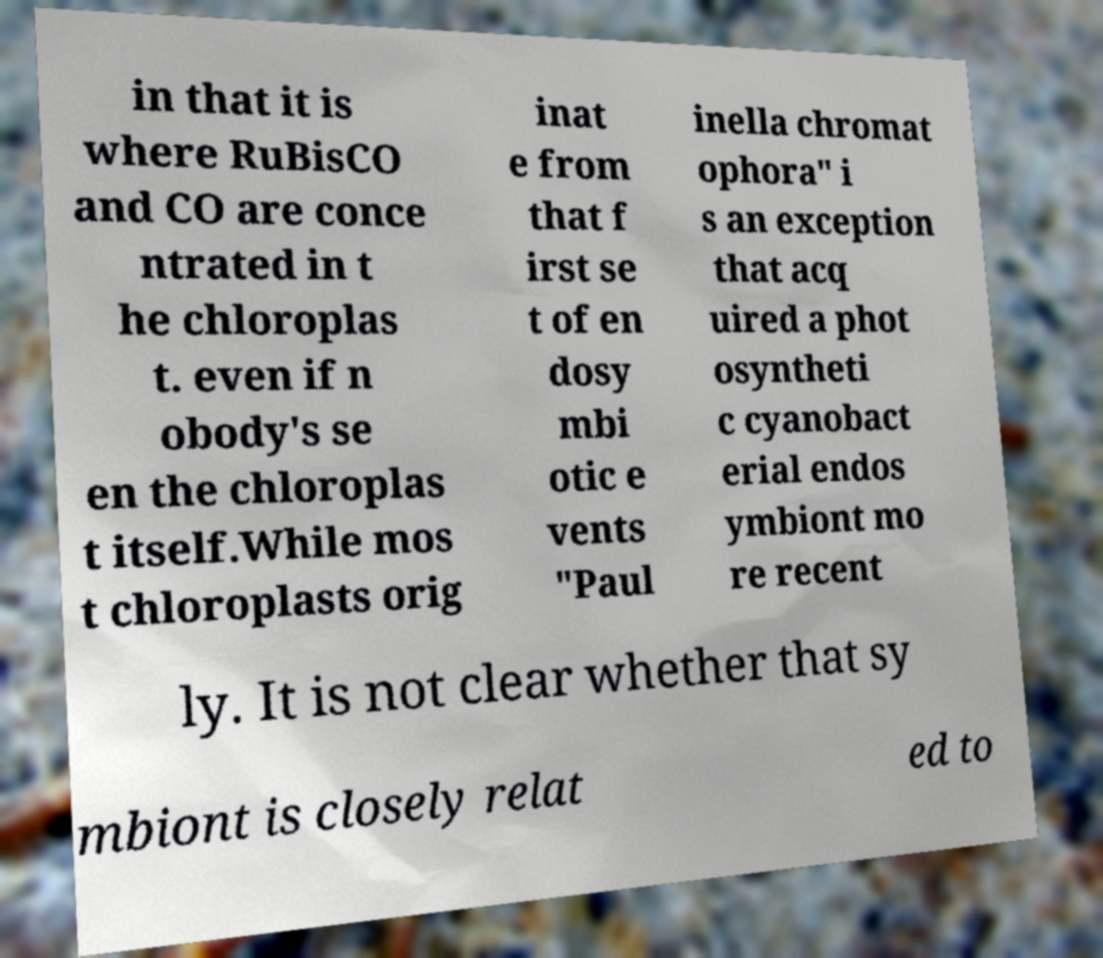Can you accurately transcribe the text from the provided image for me? in that it is where RuBisCO and CO are conce ntrated in t he chloroplas t. even if n obody's se en the chloroplas t itself.While mos t chloroplasts orig inat e from that f irst se t of en dosy mbi otic e vents "Paul inella chromat ophora" i s an exception that acq uired a phot osyntheti c cyanobact erial endos ymbiont mo re recent ly. It is not clear whether that sy mbiont is closely relat ed to 